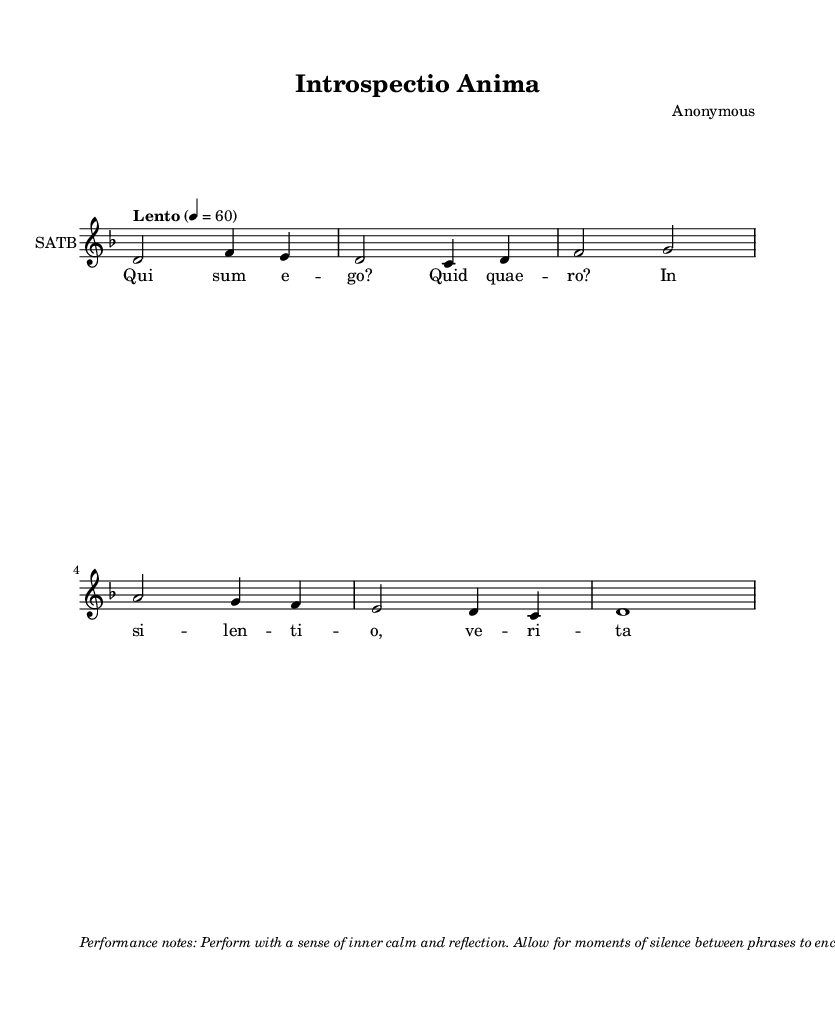What is the key signature of this music? The sheet music indicates the key signature is D minor, which is identifiable from the presence of one flat (B flat) in the key signature section at the beginning of the staff.
Answer: D minor What is the time signature of this music? The time signature shown is 4/4, which can be seen at the beginning of the score after the key signature. This means there are four beats in each measure and the quarter note is given one beat.
Answer: 4/4 What is the tempo marking of this music? The tempo marking indicated is "Lento," which suggests a slow pace. This can be deduced from the phrasing "Lento" above the staff, along with the metronome marking of 60 beats per minute.
Answer: Lento What is the total number of measures in the piece? The piece consists of 5 measures, as counted from the beginning to the end of the melody line. Each group of notes separated by vertical lines (bar lines) represents one measure.
Answer: 5 What emotion or feeling does this Gregorian chant aim to evoke? The chant is designed to evoke introspection and self-reflection, which is implied by the performance notes instructing the performer to maintain calmness and allow for moments of silence, enhancing meditation.
Answer: Introspection What type of vocal arrangements are indicated in the score? The score indicates SATB, which stands for Soprano, Alto, Tenor, and Bass vocal arrangements. This can be noted within the staff settings where "SATB" is specified as the instrument name.
Answer: SATB What is the significance of the moments of silence indicated in the performance notes? The moments of silence are essential for fostering introspection during the performance, and they encourage the listener and performer alike to reflect on the emotions conveyed by the music; this is an important aspect of meditative practices.
Answer: Reflection 